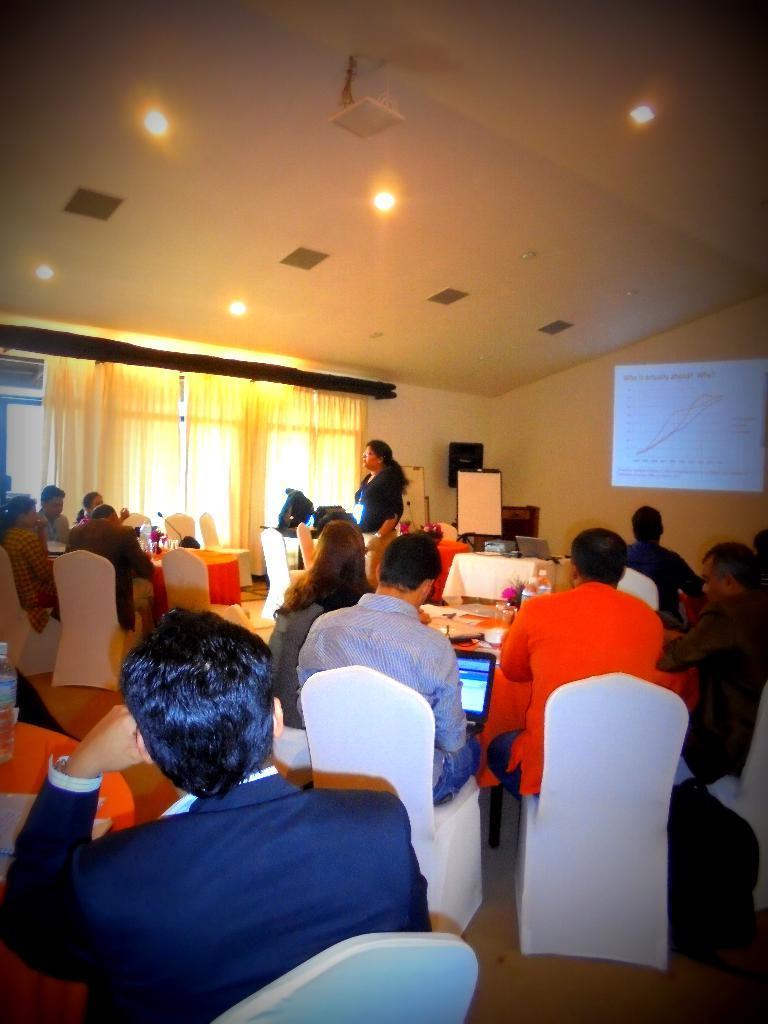Describe this image in one or two sentences. In this picture we can find some people are sitting on the chairs holding a laptop and one man standing, in the background we can find a curtain, screen, a wall. The ceiling there are lights. 